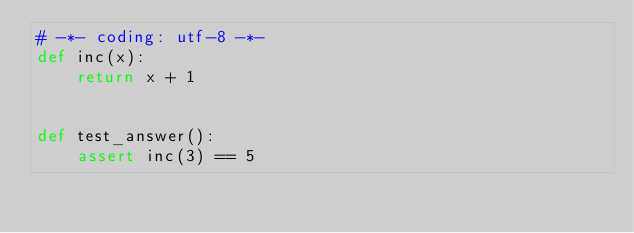<code> <loc_0><loc_0><loc_500><loc_500><_Python_># -*- coding: utf-8 -*-
def inc(x):
    return x + 1


def test_answer():
    assert inc(3) == 5
</code> 